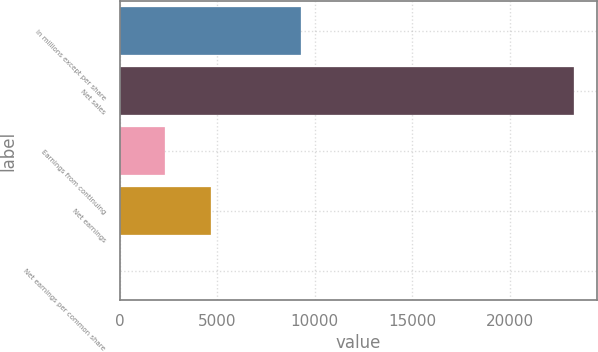<chart> <loc_0><loc_0><loc_500><loc_500><bar_chart><fcel>In millions except per share<fcel>Net sales<fcel>Earnings from continuing<fcel>Net earnings<fcel>Net earnings per common share<nl><fcel>9317.01<fcel>23289<fcel>2331.03<fcel>4659.69<fcel>2.37<nl></chart> 